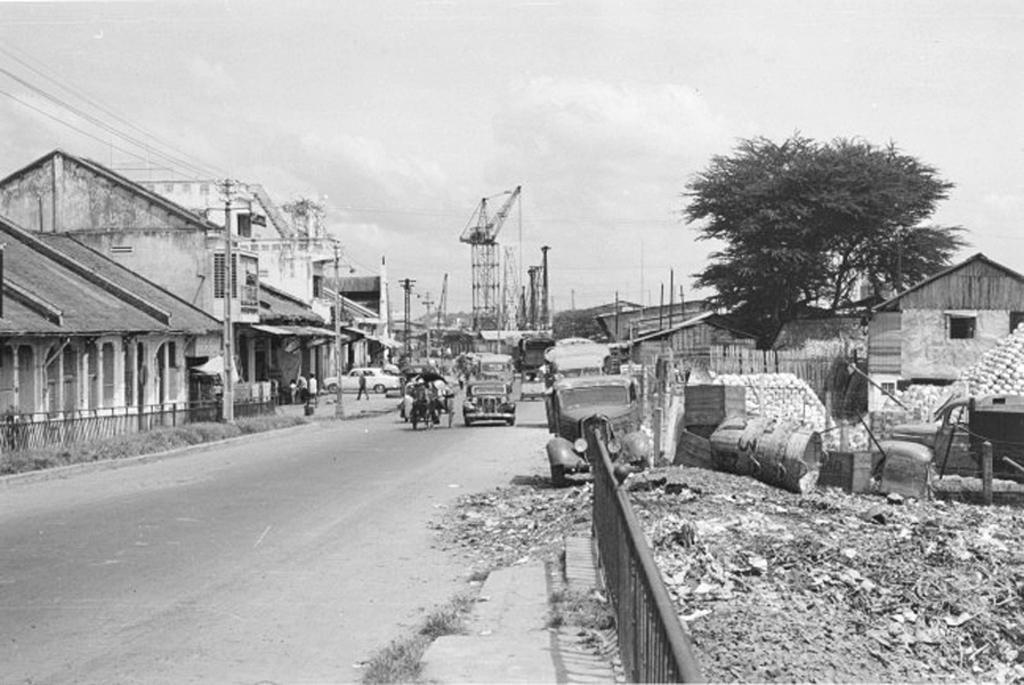How would you summarize this image in a sentence or two? In this image there are vehicles on the road. There are a few people standing. There are bushes, railings, electrical poles with cables, buildings, trees, towers. On the right side of the image there is a garbage and there are a few objects. At the top of the image there is sky. 